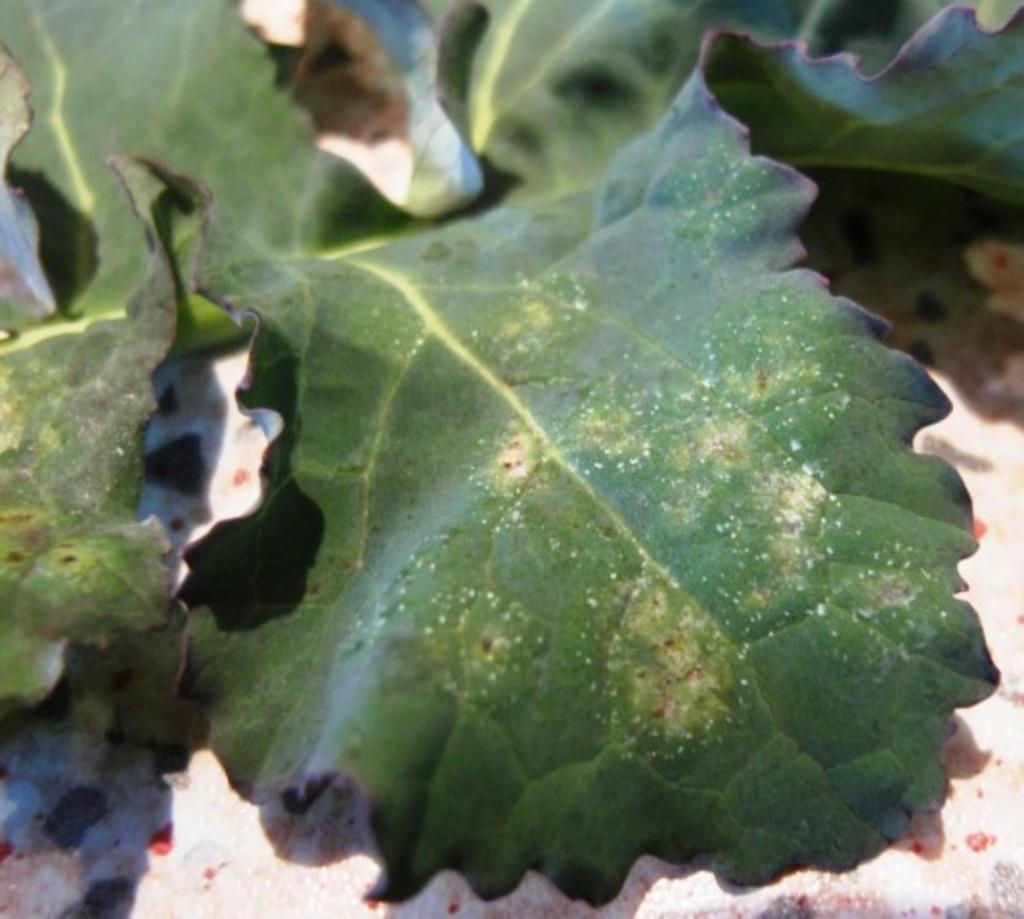What is on the floor in the image? There are leaves on the floor in the image. Can you describe the leaves in the image? The leaves are likely from a tree or plant, and they are scattered on the floor. What might be the reason for the leaves being on the floor? The leaves may have fallen from a tree or been intentionally placed on the floor. How many people are in the crowd in the image? There is no crowd present in the image; it only features leaves on the floor. What is the smell of the leaves in the image? The image does not provide any information about the smell of the leaves, as it is a visual medium. 